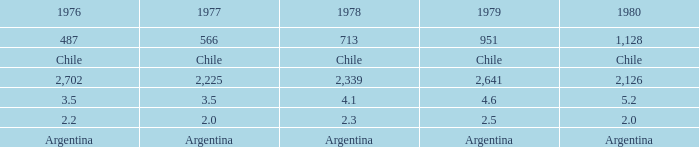What is 1977 when 1980 is chile? Chile. 